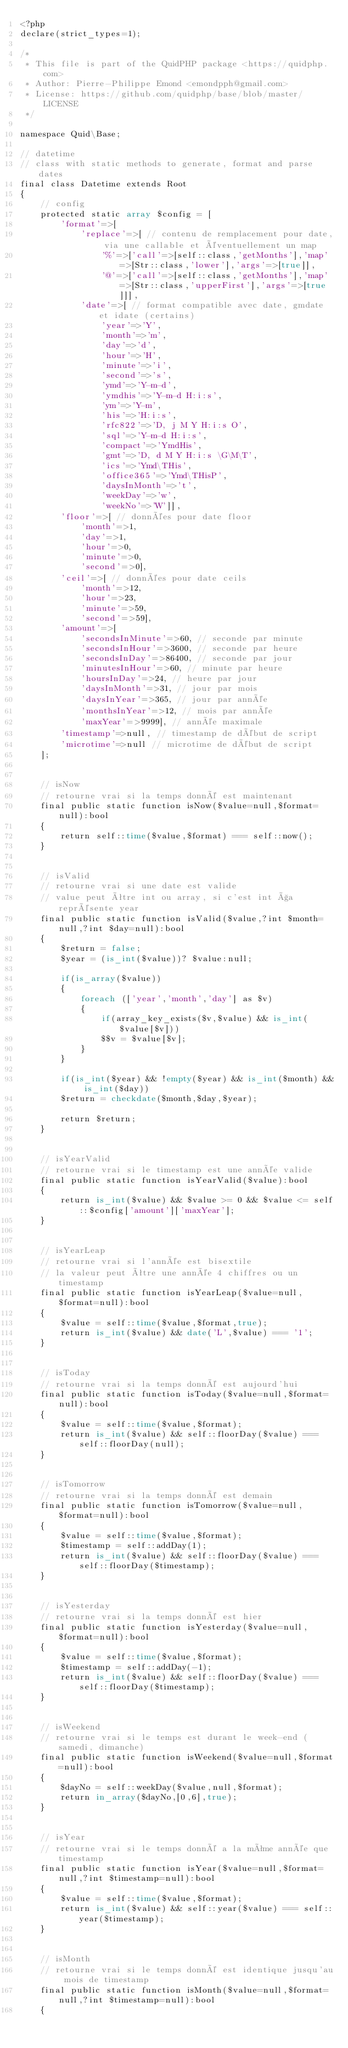<code> <loc_0><loc_0><loc_500><loc_500><_PHP_><?php
declare(strict_types=1);

/*
 * This file is part of the QuidPHP package <https://quidphp.com>
 * Author: Pierre-Philippe Emond <emondpph@gmail.com>
 * License: https://github.com/quidphp/base/blob/master/LICENSE
 */

namespace Quid\Base;

// datetime
// class with static methods to generate, format and parse dates
final class Datetime extends Root
{
    // config
    protected static array $config = [
        'format'=>[
            'replace'=>[ // contenu de remplacement pour date, via une callable et éventuellement un map
                '%'=>['call'=>[self::class,'getMonths'],'map'=>[Str::class,'lower'],'args'=>[true]],
                '@'=>['call'=>[self::class,'getMonths'],'map'=>[Str::class,'upperFirst'],'args'=>[true]]],
            'date'=>[ // format compatible avec date, gmdate et idate (certains)
                'year'=>'Y',
                'month'=>'m',
                'day'=>'d',
                'hour'=>'H',
                'minute'=>'i',
                'second'=>'s',
                'ymd'=>'Y-m-d',
                'ymdhis'=>'Y-m-d H:i:s',
                'ym'=>'Y-m',
                'his'=>'H:i:s',
                'rfc822'=>'D, j M Y H:i:s O',
                'sql'=>'Y-m-d H:i:s',
                'compact'=>'YmdHis',
                'gmt'=>'D, d M Y H:i:s \G\M\T',
                'ics'=>'Ymd\THis',
                'office365'=>'Ymd\THisP',
                'daysInMonth'=>'t',
                'weekDay'=>'w',
                'weekNo'=>'W']],
        'floor'=>[ // données pour date floor
            'month'=>1,
            'day'=>1,
            'hour'=>0,
            'minute'=>0,
            'second'=>0],
        'ceil'=>[ // données pour date ceils
            'month'=>12,
            'hour'=>23,
            'minute'=>59,
            'second'=>59],
        'amount'=>[
            'secondsInMinute'=>60, // seconde par minute
            'secondsInHour'=>3600, // seconde par heure
            'secondsInDay'=>86400, // seconde par jour
            'minutesInHour'=>60, // minute par heure
            'hoursInDay'=>24, // heure par jour
            'daysInMonth'=>31, // jour par mois
            'daysInYear'=>365, // jour par année
            'monthsInYear'=>12, // mois par année
            'maxYear'=>9999], // année maximale
        'timestamp'=>null, // timestamp de début de script
        'microtime'=>null // microtime de début de script
    ];


    // isNow
    // retourne vrai si la temps donné est maintenant
    final public static function isNow($value=null,$format=null):bool
    {
        return self::time($value,$format) === self::now();
    }


    // isValid
    // retourne vrai si une date est valide
    // value peut être int ou array, si c'est int ça représente year
    final public static function isValid($value,?int $month=null,?int $day=null):bool
    {
        $return = false;
        $year = (is_int($value))? $value:null;

        if(is_array($value))
        {
            foreach (['year','month','day'] as $v)
            {
                if(array_key_exists($v,$value) && is_int($value[$v]))
                $$v = $value[$v];
            }
        }

        if(is_int($year) && !empty($year) && is_int($month) && is_int($day))
        $return = checkdate($month,$day,$year);

        return $return;
    }


    // isYearValid
    // retourne vrai si le timestamp est une année valide
    final public static function isYearValid($value):bool
    {
        return is_int($value) && $value >= 0 && $value <= self::$config['amount']['maxYear'];
    }


    // isYearLeap
    // retourne vrai si l'année est bisextile
    // la valeur peut être une année 4 chiffres ou un timestamp
    final public static function isYearLeap($value=null,$format=null):bool
    {
        $value = self::time($value,$format,true);
        return is_int($value) && date('L',$value) === '1';
    }


    // isToday
    // retourne vrai si la temps donné est aujourd'hui
    final public static function isToday($value=null,$format=null):bool
    {
        $value = self::time($value,$format);
        return is_int($value) && self::floorDay($value) === self::floorDay(null);
    }


    // isTomorrow
    // retourne vrai si la temps donné est demain
    final public static function isTomorrow($value=null,$format=null):bool
    {
        $value = self::time($value,$format);
        $timestamp = self::addDay(1);
        return is_int($value) && self::floorDay($value) === self::floorDay($timestamp);
    }


    // isYesterday
    // retourne vrai si la temps donné est hier
    final public static function isYesterday($value=null,$format=null):bool
    {
        $value = self::time($value,$format);
        $timestamp = self::addDay(-1);
        return is_int($value) && self::floorDay($value) === self::floorDay($timestamp);
    }


    // isWeekend
    // retourne vrai si le temps est durant le week-end (samedi, dimanche)
    final public static function isWeekend($value=null,$format=null):bool
    {
        $dayNo = self::weekDay($value,null,$format);
        return in_array($dayNo,[0,6],true);
    }


    // isYear
    // retourne vrai si le temps donné a la même année que timestamp
    final public static function isYear($value=null,$format=null,?int $timestamp=null):bool
    {
        $value = self::time($value,$format);
        return is_int($value) && self::year($value) === self::year($timestamp);
    }


    // isMonth
    // retourne vrai si le temps donné est identique jusqu'au mois de timestamp
    final public static function isMonth($value=null,$format=null,?int $timestamp=null):bool
    {</code> 